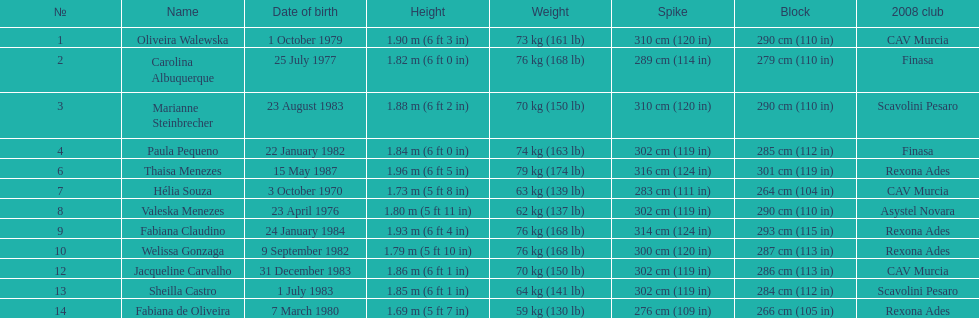Among fabiana de oliveira, helia souza, and sheilla castro, who possesses the heaviest weight? Sheilla Castro. 